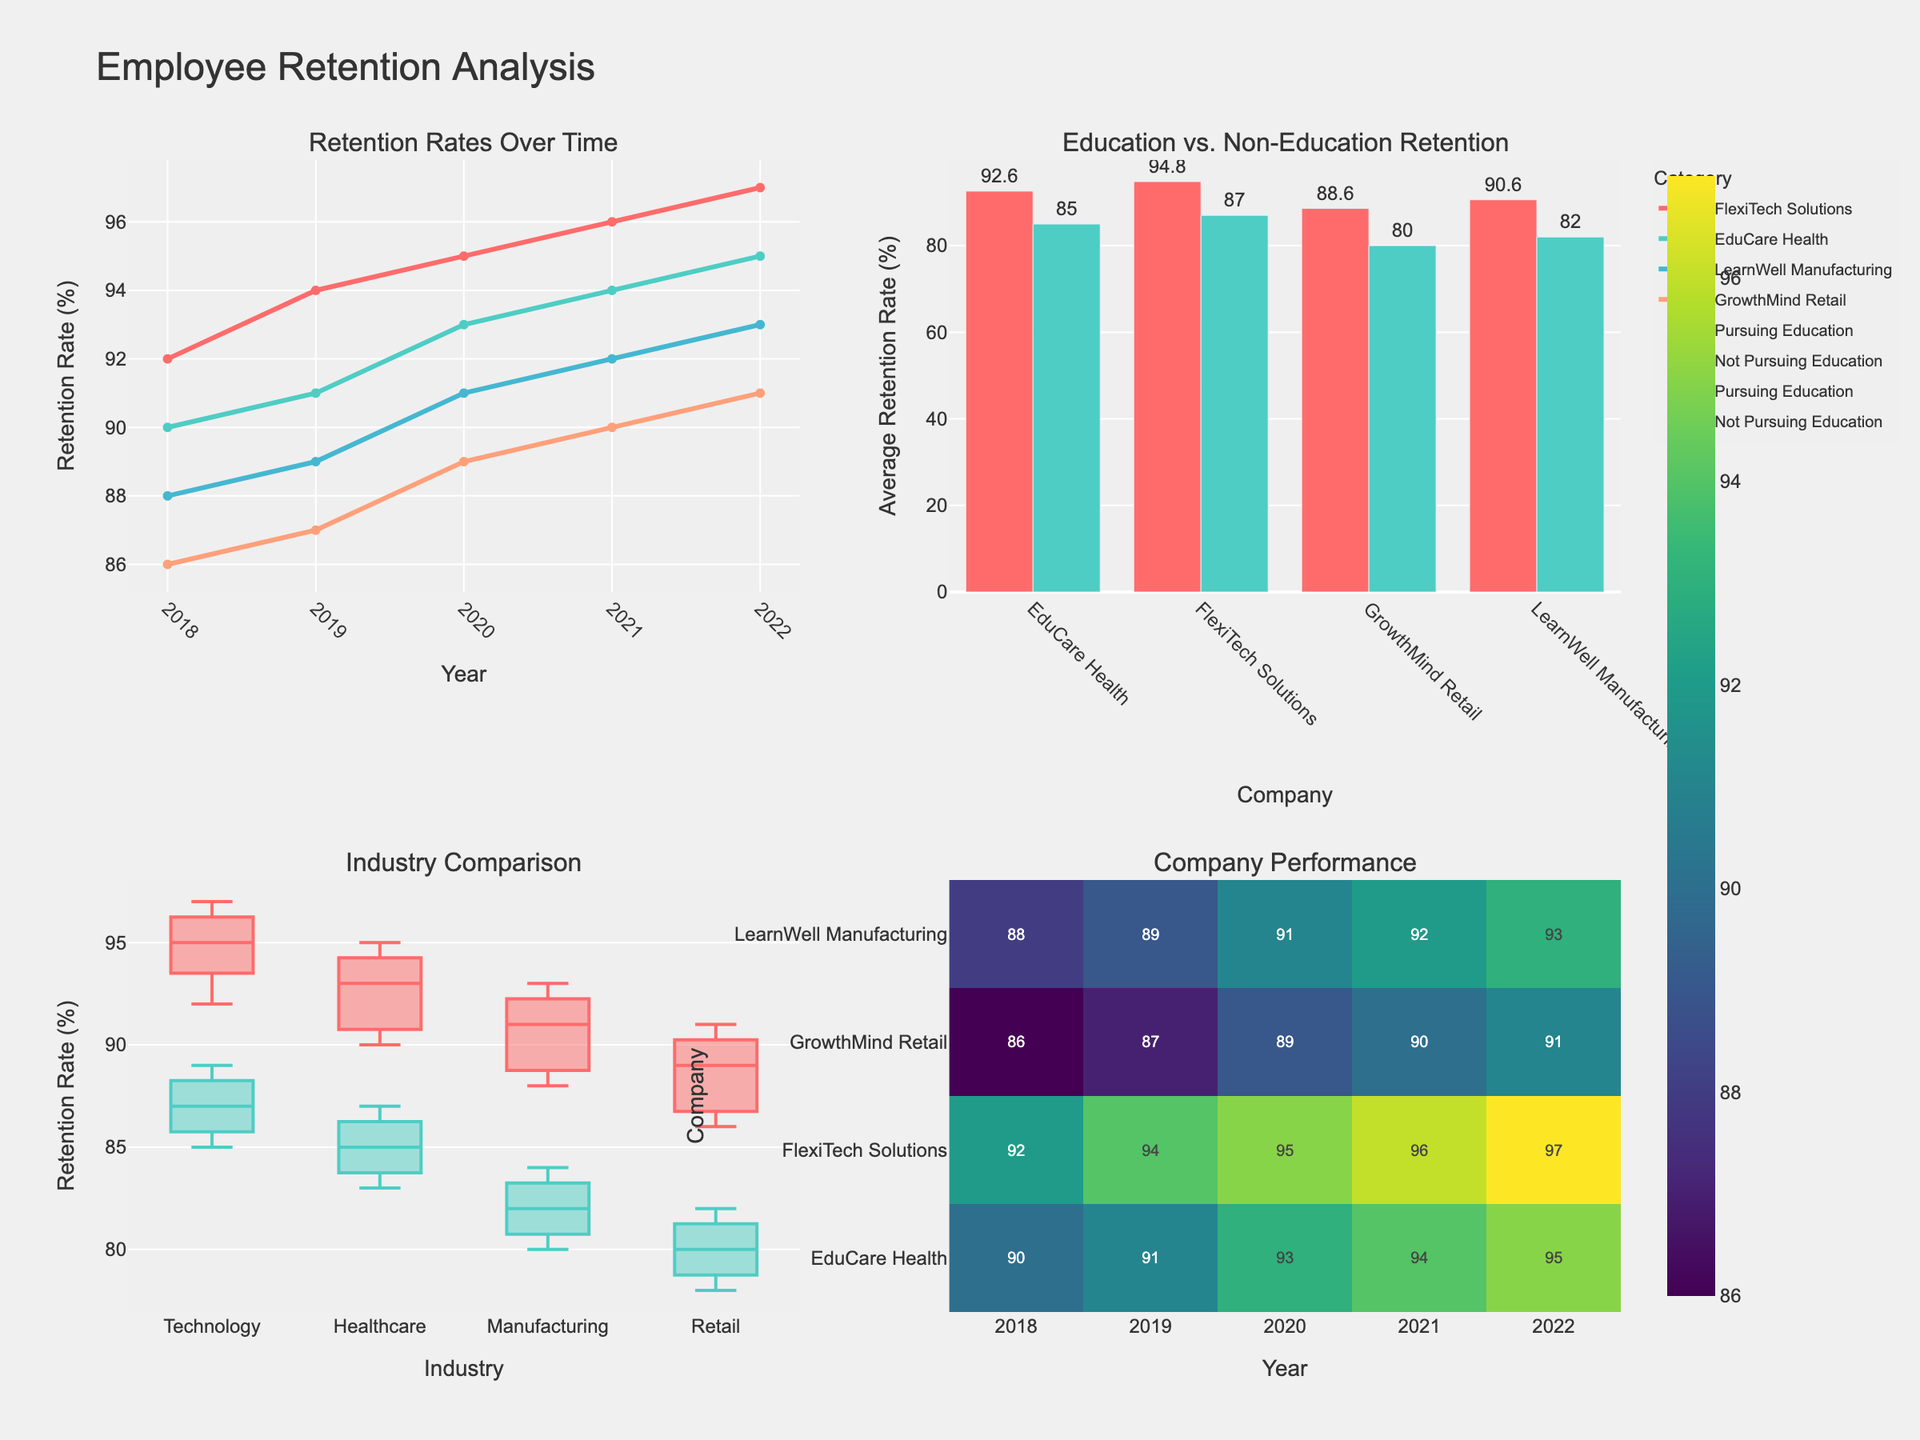What's the title of the figure? The title of a figure is typically located at the top center. In this figure, the title is clearly displayed.
Answer: Customer Satisfaction Ratings by Product Category What are the categories displayed in the subplots? The subplot titles indicate the various categories being analyzed for customer satisfaction ratings. The categories are shown at the top of each subplot.
Answer: Electronics, Clothing, Home Goods, Beauty Products, Food & Beverages Which rating has the highest count for Electronics? By observing the bar heights in the Electronics subplot, the tallest bar represents the most frequent rating.
Answer: Excellent How many "Good" ratings were given for Food & Beverages? In the Food & Beverages subplot, the bar labeled "Good" can be examined to find the count.
Answer: 32 Which product category received the highest number of "Terrible" ratings? By comparing the heights of the "Terrible" rating bars across all subplots, we can determine which is the highest.
Answer: Electronics What's the difference in the count of "Excellent" ratings between Electronics and Clothing? To compute the difference, subtract the "Excellent" count for Clothing from the "Excellent" count for Electronics. 45 (Electronics) - 38 (Clothing) = 7.
Answer: 7 What percentage of Home Goods ratings are "Average"? First, find the total number of ratings for Home Goods by summing all its counts. Then, calculate the percentage that the "Average" ratings represent: (18 / (42+33+18+5+2)) * 100.
Answer: 17.65% Between Beauty Products and Food & Beverages, which category has more "Poor" ratings? By examining the bar heights for the "Poor" category in both subplots, compare the values. Beauty Products has a higher bar.
Answer: Beauty Products What is the second-highest rating count for Clothing? In the Clothing subplot, identify the second-tallest bar among the rating categories.
Answer: Good 